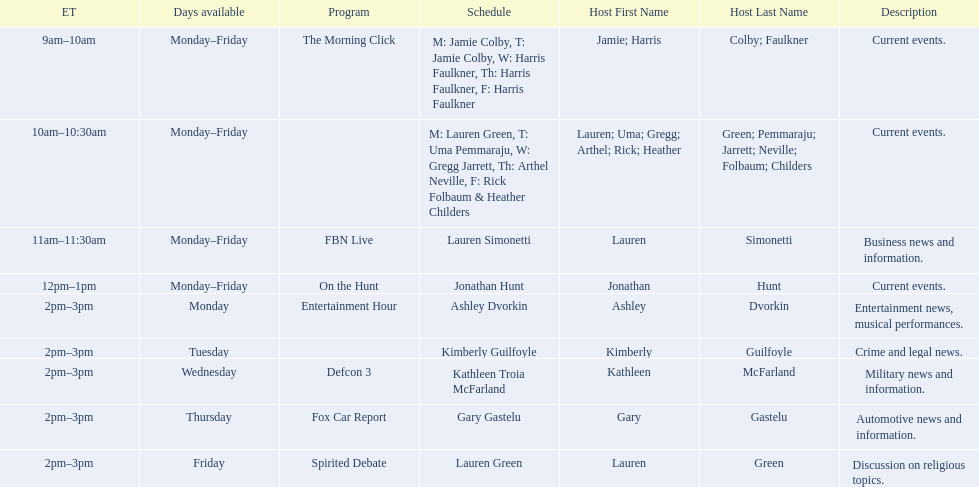What are the names of all the hosts? Jamie Colby (M,T), Harris Faulkner (W–F), Lauren Green (M), Uma Pemmaraju (T), Gregg Jarrett (W), Arthel Neville (F), Rick Folbaum (F), Heather Childers, Lauren Simonetti, Jonathan Hunt, Ashley Dvorkin, Kimberly Guilfoyle, Kathleen Troia McFarland, Gary Gastelu, Lauren Green. What hosts have a show on friday? Jamie Colby (M,T), Harris Faulkner (W–F), Lauren Green (M), Uma Pemmaraju (T), Gregg Jarrett (W), Arthel Neville (F), Rick Folbaum (F), Heather Childers, Lauren Simonetti, Jonathan Hunt, Lauren Green. Of these hosts, which is the only host with only friday available? Lauren Green. 